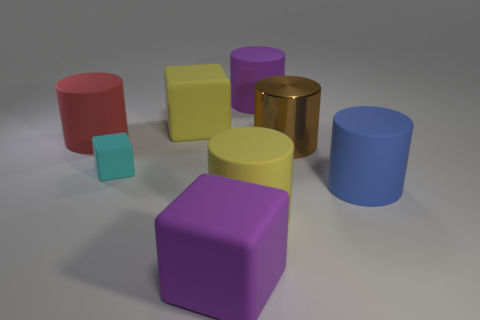Subtract all brown cylinders. How many cylinders are left? 4 Subtract all red cylinders. How many cylinders are left? 4 Subtract all gray cylinders. Subtract all gray spheres. How many cylinders are left? 5 Add 1 small cyan metallic spheres. How many objects exist? 9 Subtract all cylinders. How many objects are left? 3 Add 5 yellow matte cylinders. How many yellow matte cylinders exist? 6 Subtract 0 red cubes. How many objects are left? 8 Subtract all purple cylinders. Subtract all large red matte objects. How many objects are left? 6 Add 8 large yellow cylinders. How many large yellow cylinders are left? 9 